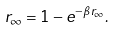Convert formula to latex. <formula><loc_0><loc_0><loc_500><loc_500>r _ { \infty } = 1 - e ^ { - \beta r _ { \infty } } .</formula> 